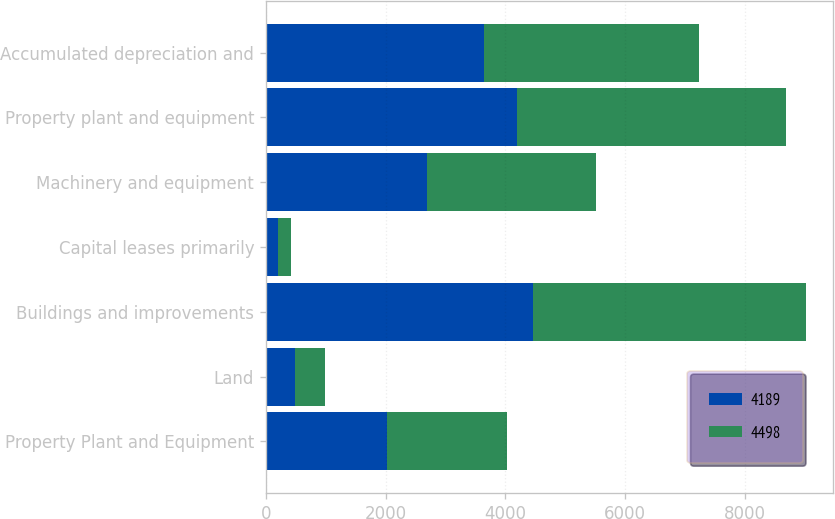Convert chart to OTSL. <chart><loc_0><loc_0><loc_500><loc_500><stacked_bar_chart><ecel><fcel>Property Plant and Equipment<fcel>Land<fcel>Buildings and improvements<fcel>Capital leases primarily<fcel>Machinery and equipment<fcel>Property plant and equipment<fcel>Accumulated depreciation and<nl><fcel>4189<fcel>2015<fcel>480<fcel>4462<fcel>203<fcel>2687<fcel>4189<fcel>3643<nl><fcel>4498<fcel>2014<fcel>506<fcel>4549<fcel>210<fcel>2817<fcel>4498<fcel>3584<nl></chart> 